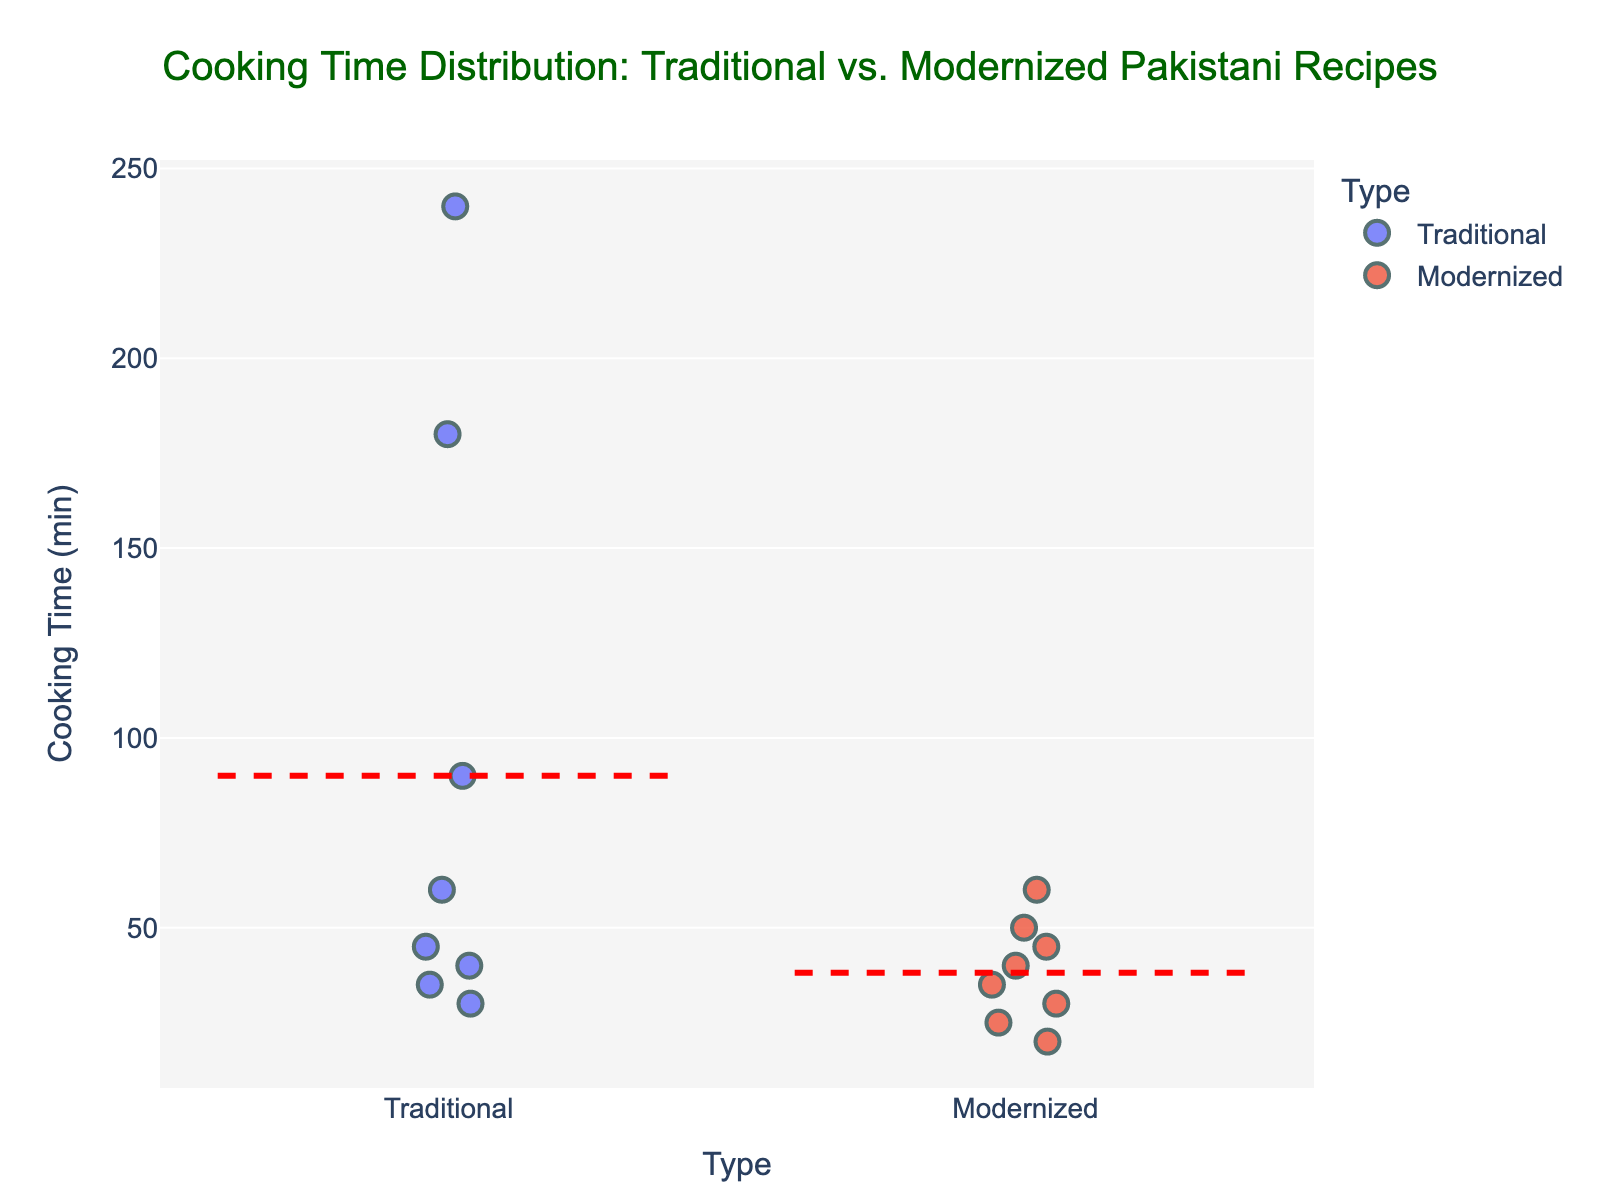What is the title of the plot? The title is usually placed at the top of the graph. In this case, look at the top section of the figure to find the title.
Answer: Cooking Time Distribution: Traditional vs. Modernized Pakistani Recipes What are the two types of recipes shown in the plot? The x-axis shows the categories being compared. In this plot, there are two categories labeled on the x-axis.
Answer: Traditional and Modernized What is the cooking time for Beef Nihari? By hovering over or checking the specific points corresponding to each recipe, you can find the exact cooking time for Beef Nihari.
Answer: 180 minutes Which recipe has the shortest cooking time among the modernized recipes? Look at the points plotted under the 'Modernized' category and identify the lowest point on the y-axis, then check the recipe name associated with it.
Answer: Masala Fries with Raita Dip Which type of recipe has the greater average cooking time? The plot includes red dashed lines indicating the mean cooking times. Compare the positions of these lines for 'Traditional' and 'Modernized' categories.
Answer: Traditional How many traditional recipes have a cooking time greater than 60 minutes? Identify the 'Traditional' category on the x-axis and count the number of points above the 60-minute mark on the y-axis.
Answer: 3 What is the average cooking time for modernized recipes? Find the red dashed line under the 'Modernized' category, which indicates the average cooking time.
Answer: 37.14 minutes (approximately) Which recipe has the longest cooking time among all the recipes? Look for the highest point on the y-axis regardless of the category and then check the recipe name associated with it.
Answer: Haleem Are there more traditional recipes or modernized recipes? Count the number of points within each category, 'Traditional' and 'Modernized' respectively.
Answer: Traditional Which recipe has a cooking time of 50 minutes among the modernized recipes? Identify the point under the 'Modernized' category at the 50-minute mark on the y-axis and then check the recipe name associated with it.
Answer: Zarda Rice with Nutella 